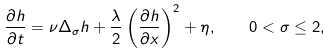<formula> <loc_0><loc_0><loc_500><loc_500>\frac { \partial h } { \partial t } = \nu \Delta _ { \sigma } h + \frac { \lambda } { 2 } \left ( \frac { \partial h } { \partial x } \right ) ^ { 2 } + \eta , \quad 0 < \sigma \leq 2 ,</formula> 